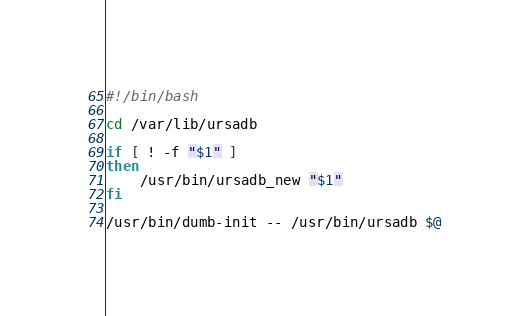<code> <loc_0><loc_0><loc_500><loc_500><_Bash_>#!/bin/bash

cd /var/lib/ursadb

if [ ! -f "$1" ]
then
    /usr/bin/ursadb_new "$1"
fi

/usr/bin/dumb-init -- /usr/bin/ursadb $@

</code> 